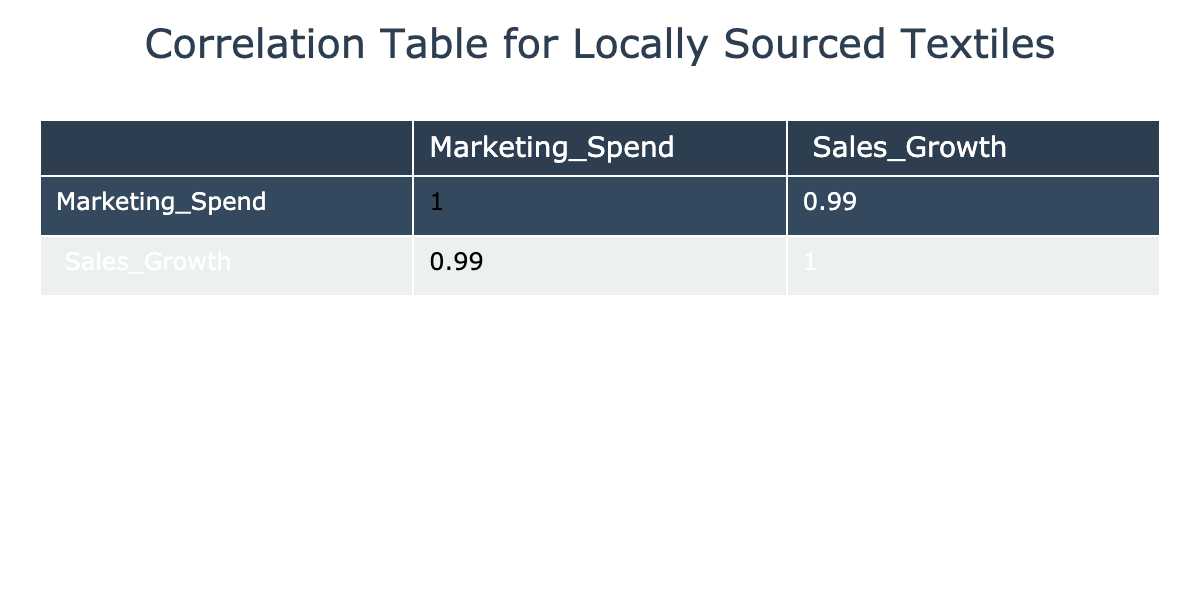What is the correlation coefficient between marketing spend and sales growth? The correlation matrix indicates the correlation coefficient for these two variables, which is located in the corresponding cell. By inspecting the table, we find that the correlation coefficient is 0.97.
Answer: 0.97 Which marketing spend results in the highest sales growth? To determine this, we look for the row with the maximum sales growth value in the Sales_Growth column, which is 40, corresponding to a marketing spend of 6000.
Answer: 6000 What is the average sales growth for marketing spends above 3000? First, we identify the marketing spends above 3000: 3500, 4000, 4500, 5000, and 6000, which have corresponding sales growth values of 18, 25, 30, 35, and 40. Their sum is 148, and there are 5 entries. So, the average is 148/5 = 29.6.
Answer: 29.6 Is there a marketing spend that does not lead to any sales growth? We scan the table for any sales growth entries equal to zero. There is no entry in the Sales_Growth column which is zero, meaning all marketing spends resulted in some sales growth.
Answer: No What is the difference in sales growth between the highest and lowest marketing spend? The highest marketing spend is 6000 with a sales growth of 40, and the lowest is 1000 with a sales growth of 5. To find the difference, we subtract 5 from 40, yielding a difference of 35.
Answer: 35 What is the total marketing spend when sales growth is greater than 20? We identify the marketing spends corresponding to sales growth greater than 20, which are for 25, 30, 35, and 40. The associated marketing spends are 4000, 4500, 5000, and 6000. Adding these gives us 4000 + 4500 + 5000 + 6000 = 19500.
Answer: 19500 How many rows show a sales growth of 15 or higher? We examine the Sales_Growth column for values equal to or greater than 15. The rows corresponding to sales growths of 15, 20, 25, 30, 35, and 40 meet the criteria. There are 6 such entries in total.
Answer: 6 If we increase marketing spend by 1000 for all entries, what would be the new correlation coefficient? While the table does not explicitly provide the new correlation coefficient, adding a constant to all values of one variable does not change the correlation; it remains the same. Therefore, the correlation coefficient would still be 0.97.
Answer: 0.97 What is the lowest level of marketing spend that resulted in sales growth of 12 or higher? We look for the smallest marketing spend in the table that has a corresponding sales growth of at least 12. The values for 12, 15, 20, 25, and higher correspond to marketing spends of 2000, 2500, and higher, with the minimum being 2000.
Answer: 2000 